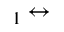<formula> <loc_0><loc_0><loc_500><loc_500>_ { 1 } \leftrightarrow</formula> 